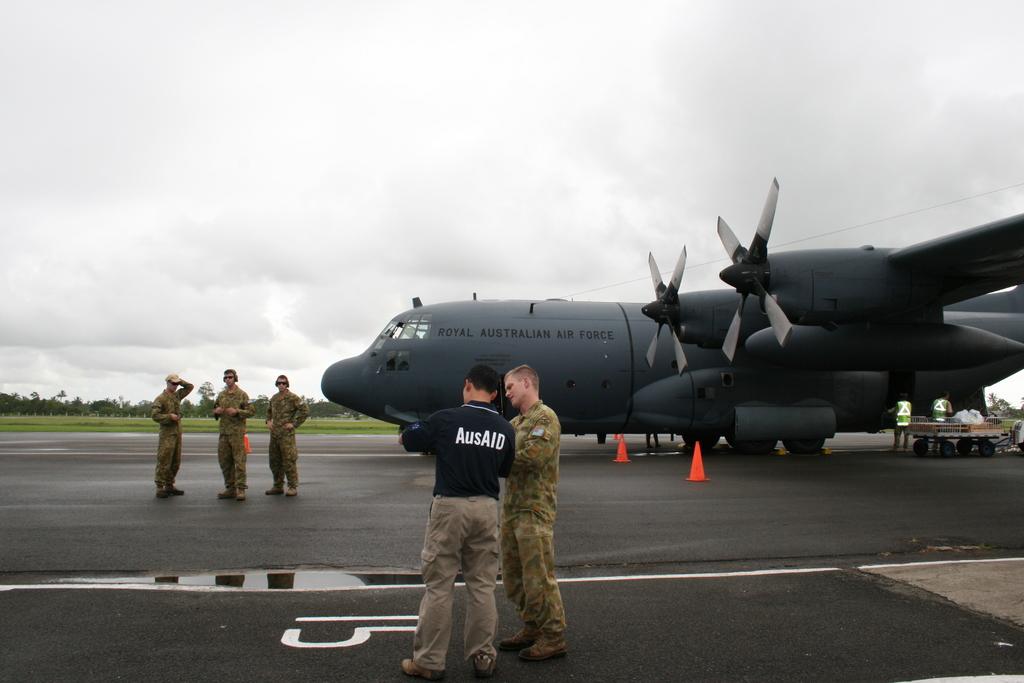What does that back of his shirt say?
Offer a very short reply. Ausaid. 